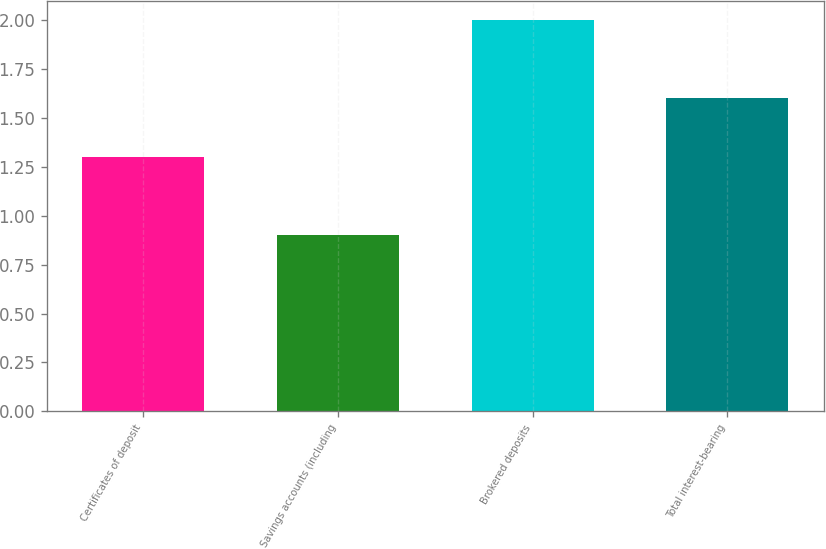Convert chart. <chart><loc_0><loc_0><loc_500><loc_500><bar_chart><fcel>Certificates of deposit<fcel>Savings accounts (including<fcel>Brokered deposits<fcel>Total interest-bearing<nl><fcel>1.3<fcel>0.9<fcel>2<fcel>1.6<nl></chart> 